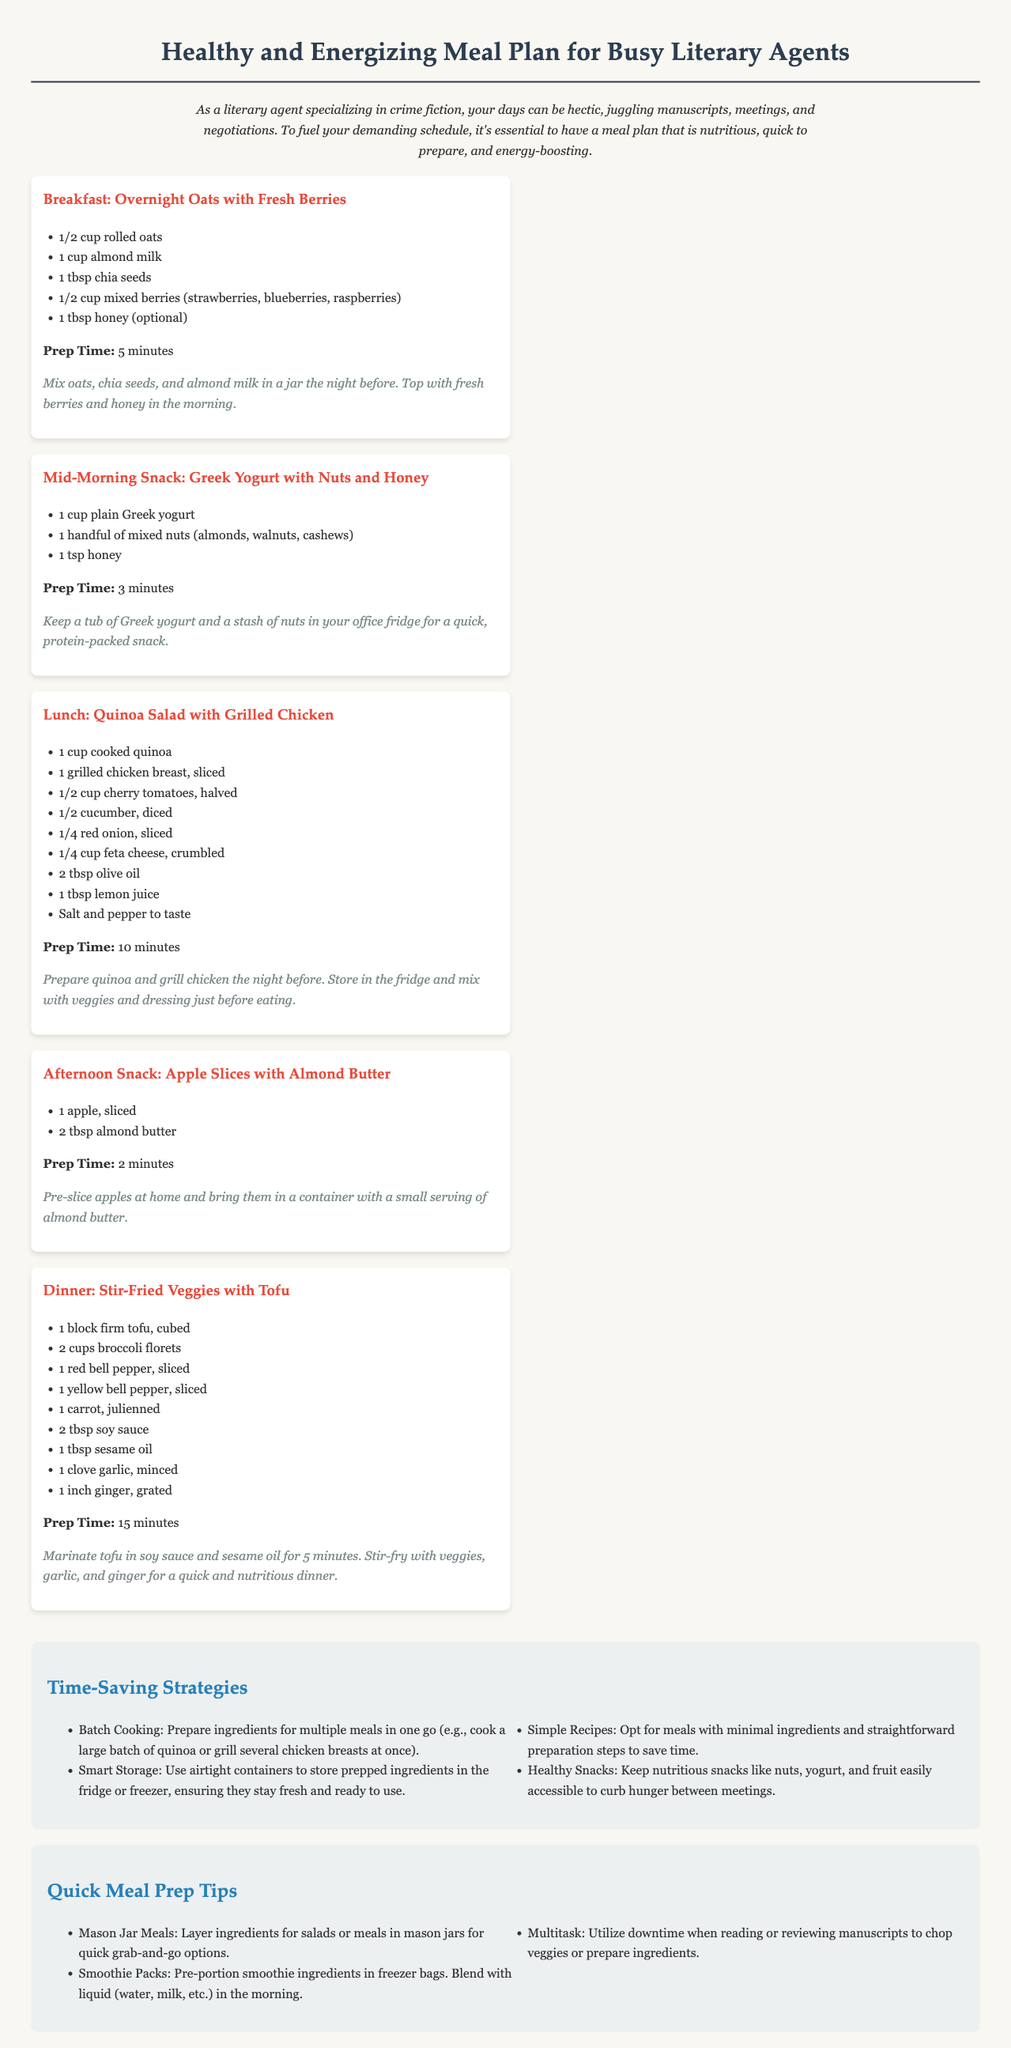What is the meal prep time for breakfast? The meal prep time for breakfast is stated as 5 minutes in the document.
Answer: 5 minutes What is included in the quinoa salad for lunch? The quinoa salad for lunch includes cooked quinoa, grilled chicken, cherry tomatoes, cucumber, red onion, feta cheese, olive oil, and lemon juice.
Answer: Grilled chicken How long does it take to prepare the afternoon snack? The afternoon snack preparation time is noted as 2 minutes in the document.
Answer: 2 minutes What is a time-saving strategy mentioned in the document? The document mentions batch cooking as a time-saving strategy for busy literary agents.
Answer: Batch cooking How can smoothie ingredients be prepped for convenience? The document suggests pre-portioning smoothie ingredients in freezer bags for convenience.
Answer: Freezer bags What is the total number of meals listed in the meal plan? There are five meals listed in the meal plan section of the document.
Answer: Five meals What type of container is recommended for storing prepped ingredients? The document recommends using airtight containers to store prepped ingredients.
Answer: Airtight containers What ingredient tops the overnight oats in the morning? The document states that fresh berries and honey top the overnight oats in the morning.
Answer: Fresh berries 